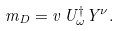Convert formula to latex. <formula><loc_0><loc_0><loc_500><loc_500>m _ { D } = v \, U _ { \omega } ^ { \dagger } Y ^ { \nu } .</formula> 